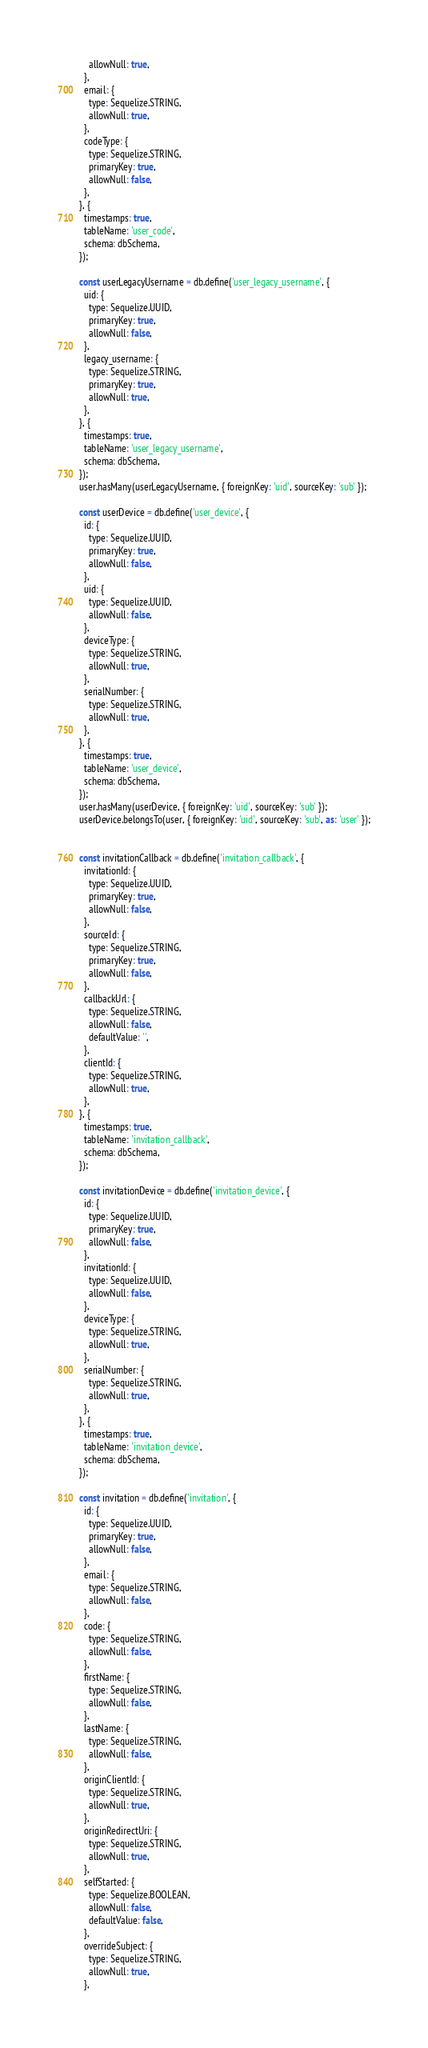<code> <loc_0><loc_0><loc_500><loc_500><_JavaScript_>    allowNull: true,
  },
  email: {
    type: Sequelize.STRING,
    allowNull: true,
  },
  codeType: {
    type: Sequelize.STRING,
    primaryKey: true,
    allowNull: false,
  },
}, {
  timestamps: true,
  tableName: 'user_code',
  schema: dbSchema,
});

const userLegacyUsername = db.define('user_legacy_username', {
  uid: {
    type: Sequelize.UUID,
    primaryKey: true,
    allowNull: false,
  },
  legacy_username: {
    type: Sequelize.STRING,
    primaryKey: true,
    allowNull: true,
  },
}, {
  timestamps: true,
  tableName: 'user_legacy_username',
  schema: dbSchema,
});
user.hasMany(userLegacyUsername, { foreignKey: 'uid', sourceKey: 'sub' });

const userDevice = db.define('user_device', {
  id: {
    type: Sequelize.UUID,
    primaryKey: true,
    allowNull: false,
  },
  uid: {
    type: Sequelize.UUID,
    allowNull: false,
  },
  deviceType: {
    type: Sequelize.STRING,
    allowNull: true,
  },
  serialNumber: {
    type: Sequelize.STRING,
    allowNull: true,
  },
}, {
  timestamps: true,
  tableName: 'user_device',
  schema: dbSchema,
});
user.hasMany(userDevice, { foreignKey: 'uid', sourceKey: 'sub' });
userDevice.belongsTo(user, { foreignKey: 'uid', sourceKey: 'sub', as: 'user' });


const invitationCallback = db.define('invitation_callback', {
  invitationId: {
    type: Sequelize.UUID,
    primaryKey: true,
    allowNull: false,
  },
  sourceId: {
    type: Sequelize.STRING,
    primaryKey: true,
    allowNull: false,
  },
  callbackUrl: {
    type: Sequelize.STRING,
    allowNull: false,
    defaultValue: '',
  },
  clientId: {
    type: Sequelize.STRING,
    allowNull: true,
  },
}, {
  timestamps: true,
  tableName: 'invitation_callback',
  schema: dbSchema,
});

const invitationDevice = db.define('invitation_device', {
  id: {
    type: Sequelize.UUID,
    primaryKey: true,
    allowNull: false,
  },
  invitationId: {
    type: Sequelize.UUID,
    allowNull: false,
  },
  deviceType: {
    type: Sequelize.STRING,
    allowNull: true,
  },
  serialNumber: {
    type: Sequelize.STRING,
    allowNull: true,
  },
}, {
  timestamps: true,
  tableName: 'invitation_device',
  schema: dbSchema,
});

const invitation = db.define('invitation', {
  id: {
    type: Sequelize.UUID,
    primaryKey: true,
    allowNull: false,
  },
  email: {
    type: Sequelize.STRING,
    allowNull: false,
  },
  code: {
    type: Sequelize.STRING,
    allowNull: false,
  },
  firstName: {
    type: Sequelize.STRING,
    allowNull: false,
  },
  lastName: {
    type: Sequelize.STRING,
    allowNull: false,
  },
  originClientId: {
    type: Sequelize.STRING,
    allowNull: true,
  },
  originRedirectUri: {
    type: Sequelize.STRING,
    allowNull: true,
  },
  selfStarted: {
    type: Sequelize.BOOLEAN,
    allowNull: false,
    defaultValue: false,
  },
  overrideSubject: {
    type: Sequelize.STRING,
    allowNull: true,
  },</code> 